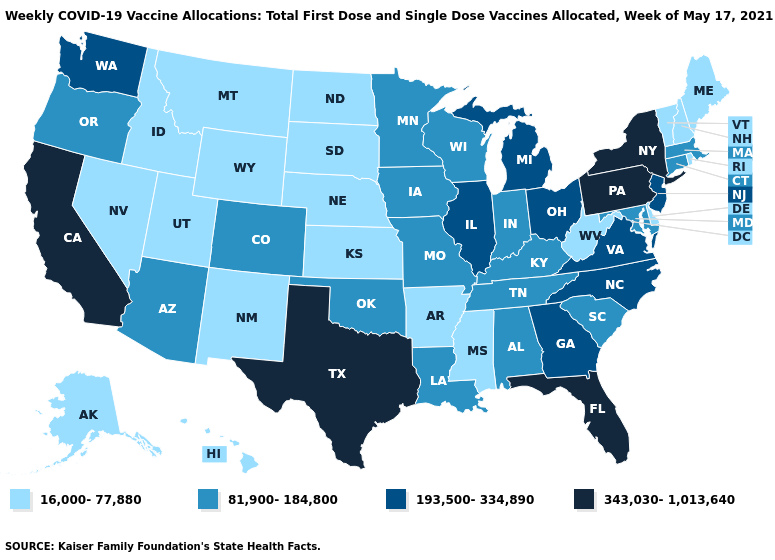Does Tennessee have the lowest value in the USA?
Quick response, please. No. Name the states that have a value in the range 193,500-334,890?
Give a very brief answer. Georgia, Illinois, Michigan, New Jersey, North Carolina, Ohio, Virginia, Washington. Name the states that have a value in the range 16,000-77,880?
Short answer required. Alaska, Arkansas, Delaware, Hawaii, Idaho, Kansas, Maine, Mississippi, Montana, Nebraska, Nevada, New Hampshire, New Mexico, North Dakota, Rhode Island, South Dakota, Utah, Vermont, West Virginia, Wyoming. Name the states that have a value in the range 343,030-1,013,640?
Quick response, please. California, Florida, New York, Pennsylvania, Texas. Name the states that have a value in the range 193,500-334,890?
Keep it brief. Georgia, Illinois, Michigan, New Jersey, North Carolina, Ohio, Virginia, Washington. Does Indiana have the lowest value in the MidWest?
Short answer required. No. What is the lowest value in the USA?
Give a very brief answer. 16,000-77,880. Does Wyoming have the lowest value in the USA?
Answer briefly. Yes. Is the legend a continuous bar?
Quick response, please. No. Name the states that have a value in the range 16,000-77,880?
Quick response, please. Alaska, Arkansas, Delaware, Hawaii, Idaho, Kansas, Maine, Mississippi, Montana, Nebraska, Nevada, New Hampshire, New Mexico, North Dakota, Rhode Island, South Dakota, Utah, Vermont, West Virginia, Wyoming. Among the states that border Nevada , does Idaho have the lowest value?
Quick response, please. Yes. What is the value of California?
Be succinct. 343,030-1,013,640. Does Nebraska have the lowest value in the MidWest?
Quick response, please. Yes. Is the legend a continuous bar?
Quick response, please. No. Does Wisconsin have the highest value in the MidWest?
Be succinct. No. 